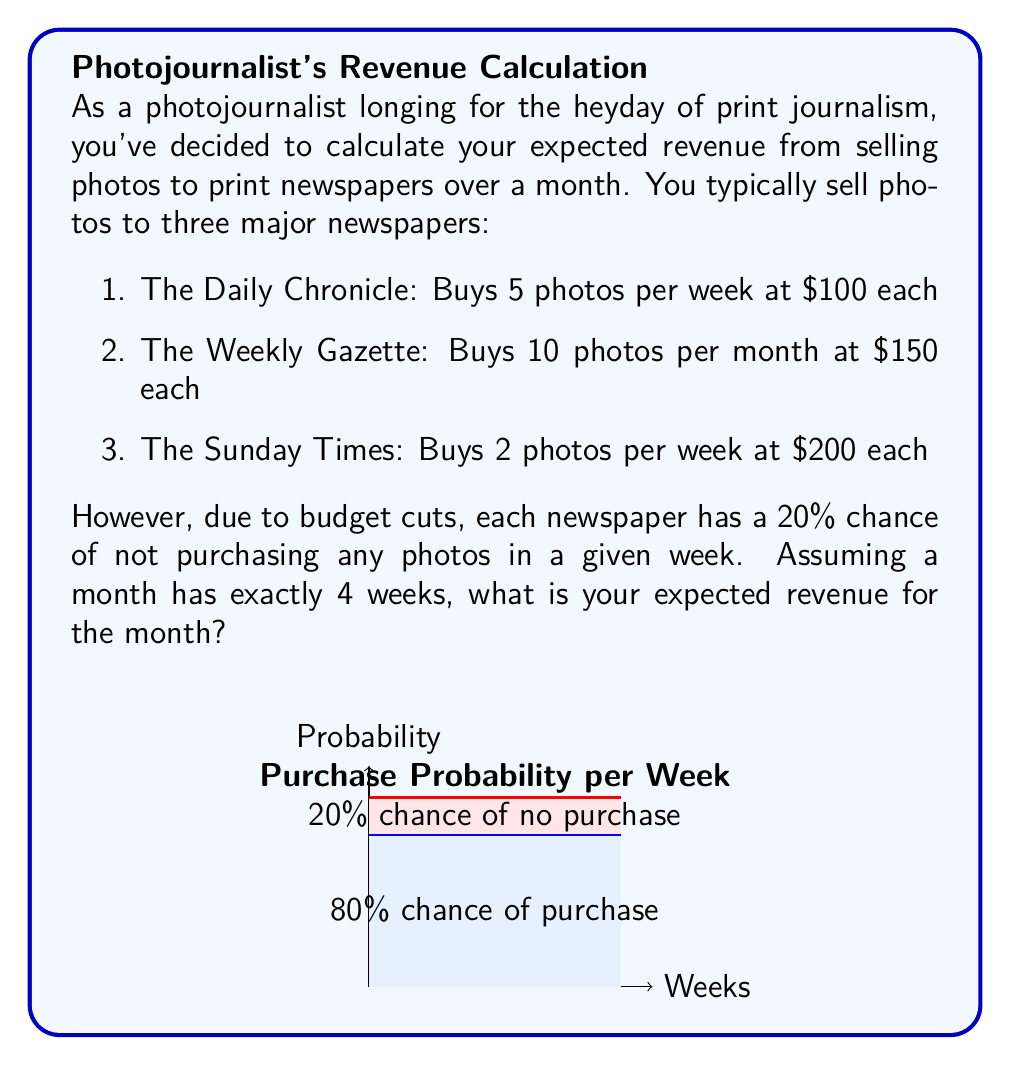What is the answer to this math problem? Let's break this down step-by-step:

1) First, let's calculate the expected revenue per week for each newspaper:

   a) The Daily Chronicle:
      Expected revenue = Probability of purchase × Number of photos × Price per photo
      $$ 0.8 \times 5 \times \$100 = \$400 $$

   b) The Weekly Gazette:
      This is monthly, so we'll divide by 4 to get weekly:
      $$ 0.8 \times (10 \div 4) \times \$150 = \$300 $$

   c) The Sunday Times:
      $$ 0.8 \times 2 \times \$200 = \$320 $$

2) Now, let's sum up the expected weekly revenue:
   $$ \$400 + \$300 + \$320 = \$1,020 $$

3) To get the monthly expected revenue, we multiply by 4 weeks:
   $$ \$1,020 \times 4 = \$4,080 $$

Therefore, the expected revenue for the month is $4,080.
Answer: $4,080 